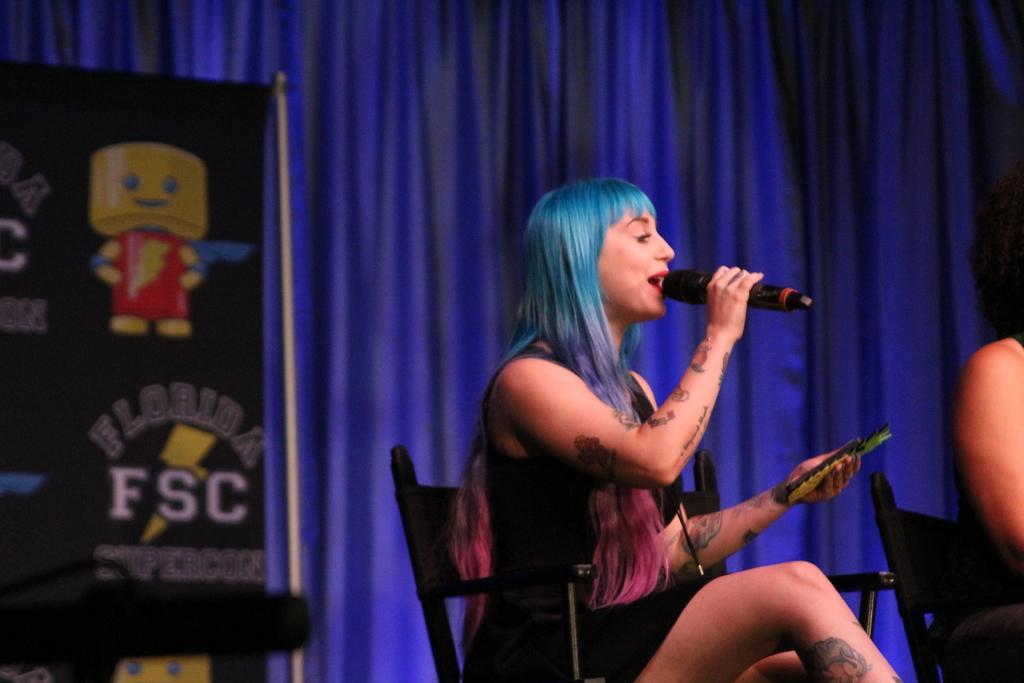Please provide a concise description of this image. In this picture there is a woman sitting in the black color chair. She is holding a mic in her hand. She is holding a black color dress. The woman's hair is in blue and purple color. We can observe a black color poster in the left side. In the background there is a blue color curtain. 